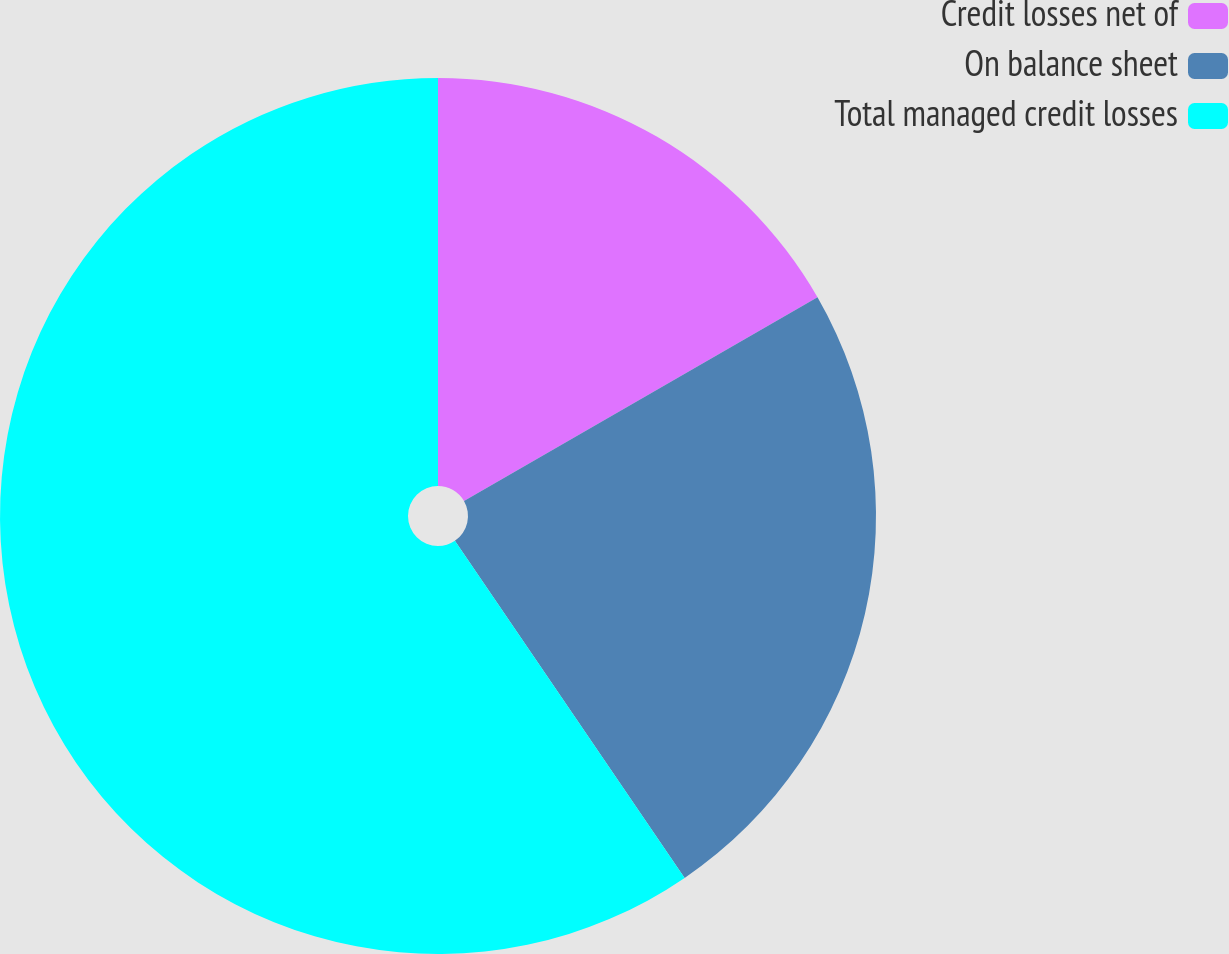Convert chart. <chart><loc_0><loc_0><loc_500><loc_500><pie_chart><fcel>Credit losses net of<fcel>On balance sheet<fcel>Total managed credit losses<nl><fcel>16.68%<fcel>23.8%<fcel>59.52%<nl></chart> 